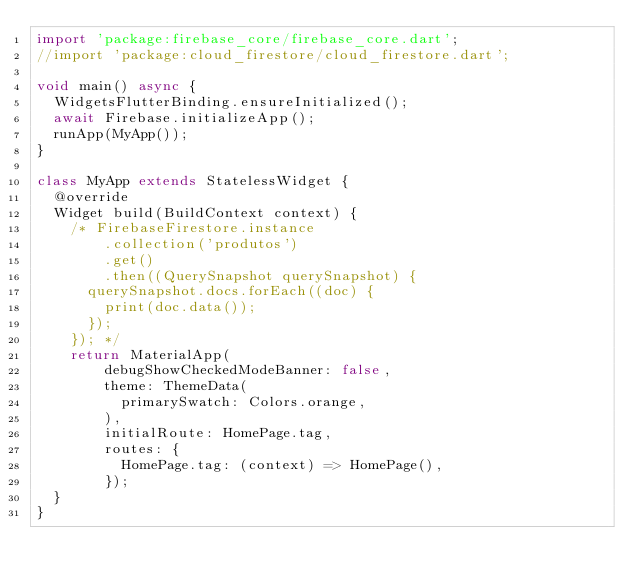<code> <loc_0><loc_0><loc_500><loc_500><_Dart_>import 'package:firebase_core/firebase_core.dart';
//import 'package:cloud_firestore/cloud_firestore.dart';

void main() async {
  WidgetsFlutterBinding.ensureInitialized();
  await Firebase.initializeApp();
  runApp(MyApp());
}

class MyApp extends StatelessWidget {
  @override
  Widget build(BuildContext context) {
    /* FirebaseFirestore.instance
        .collection('produtos')
        .get()
        .then((QuerySnapshot querySnapshot) {
      querySnapshot.docs.forEach((doc) {
        print(doc.data());
      });
    }); */
    return MaterialApp(
        debugShowCheckedModeBanner: false,
        theme: ThemeData(
          primarySwatch: Colors.orange,
        ),
        initialRoute: HomePage.tag,
        routes: {
          HomePage.tag: (context) => HomePage(),
        });
  }
}
</code> 